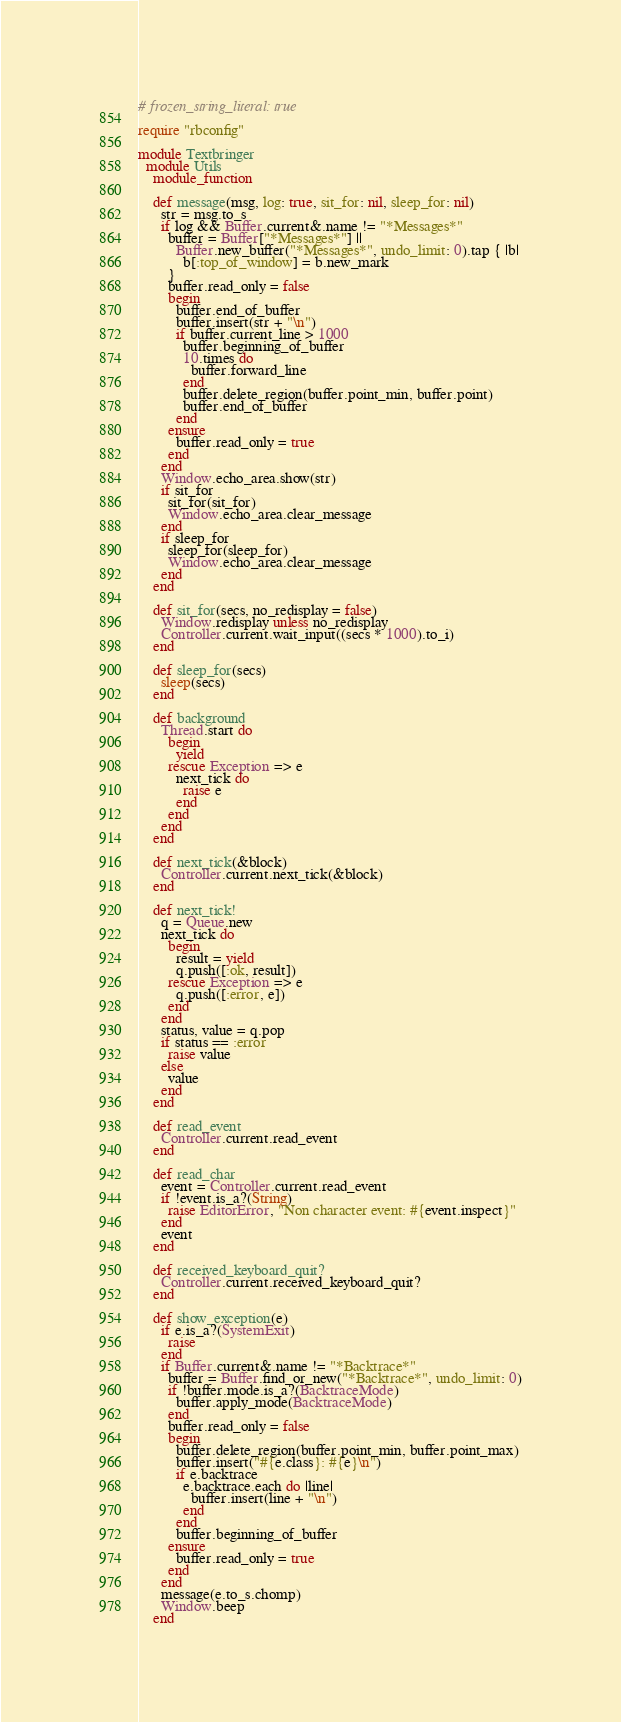<code> <loc_0><loc_0><loc_500><loc_500><_Ruby_># frozen_string_literal: true

require "rbconfig"

module Textbringer
  module Utils
    module_function

    def message(msg, log: true, sit_for: nil, sleep_for: nil)
      str = msg.to_s
      if log && Buffer.current&.name != "*Messages*"
        buffer = Buffer["*Messages*"] ||
          Buffer.new_buffer("*Messages*", undo_limit: 0).tap { |b|
            b[:top_of_window] = b.new_mark
        }
        buffer.read_only = false
        begin
          buffer.end_of_buffer
          buffer.insert(str + "\n")
          if buffer.current_line > 1000
            buffer.beginning_of_buffer
            10.times do
              buffer.forward_line
            end
            buffer.delete_region(buffer.point_min, buffer.point)
            buffer.end_of_buffer
          end
        ensure
          buffer.read_only = true
        end
      end
      Window.echo_area.show(str)
      if sit_for
        sit_for(sit_for)
        Window.echo_area.clear_message
      end
      if sleep_for
        sleep_for(sleep_for)
        Window.echo_area.clear_message
      end
    end

    def sit_for(secs, no_redisplay = false)
      Window.redisplay unless no_redisplay
      Controller.current.wait_input((secs * 1000).to_i)
    end

    def sleep_for(secs)
      sleep(secs)
    end

    def background
      Thread.start do
        begin
          yield
        rescue Exception => e
          next_tick do
            raise e
          end
        end
      end
    end

    def next_tick(&block)
      Controller.current.next_tick(&block)
    end

    def next_tick!
      q = Queue.new
      next_tick do
        begin
          result = yield
          q.push([:ok, result])
        rescue Exception => e
          q.push([:error, e])
        end
      end
      status, value = q.pop
      if status == :error
        raise value 
      else
        value
      end
    end

    def read_event
      Controller.current.read_event
    end

    def read_char
      event = Controller.current.read_event
      if !event.is_a?(String)
        raise EditorError, "Non character event: #{event.inspect}"
      end
      event
    end

    def received_keyboard_quit?
      Controller.current.received_keyboard_quit?
    end

    def show_exception(e)
      if e.is_a?(SystemExit)
        raise
      end
      if Buffer.current&.name != "*Backtrace*"
        buffer = Buffer.find_or_new("*Backtrace*", undo_limit: 0)
        if !buffer.mode.is_a?(BacktraceMode)
          buffer.apply_mode(BacktraceMode)
        end
        buffer.read_only = false
        begin
          buffer.delete_region(buffer.point_min, buffer.point_max)
          buffer.insert("#{e.class}: #{e}\n")
          if e.backtrace
            e.backtrace.each do |line|
              buffer.insert(line + "\n")
            end
          end
          buffer.beginning_of_buffer
        ensure
          buffer.read_only = true
        end
      end
      message(e.to_s.chomp)
      Window.beep
    end
</code> 